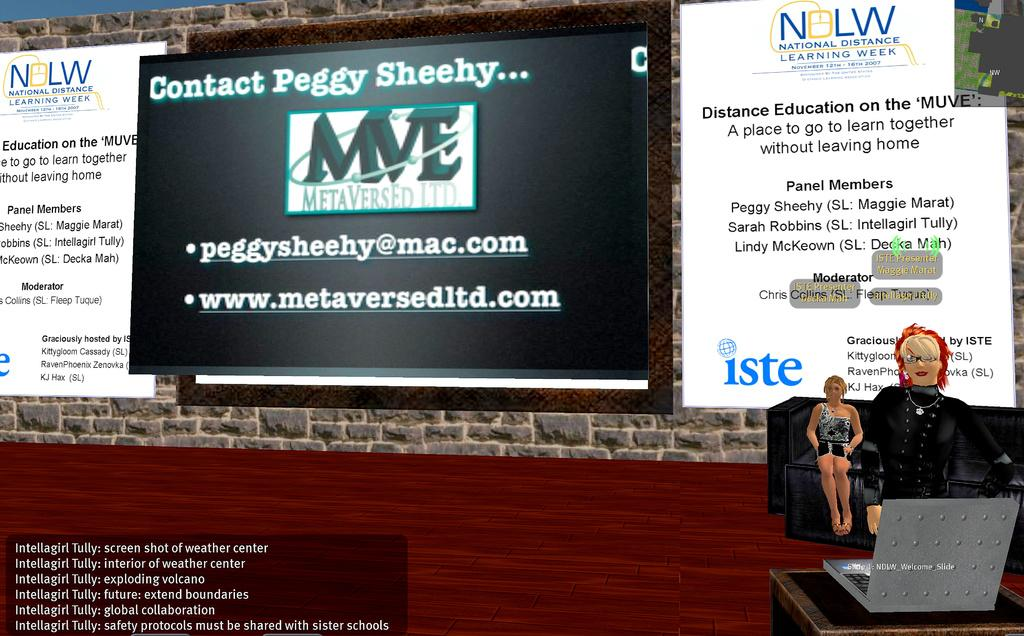What type of picture is in the image? The image contains an animated picture. Can you describe the people in the image? There are people visible in the image. What is the surface that the people and animated picture are on? There is ground visible in the image. What else can be seen on the walls or surfaces in the image? There are posters with text in the image. What type of watch is the committee wearing in the image? There is no committee or watch present in the image. How many cents are visible on the ground in the image? There are no cents visible on the ground in the image. 